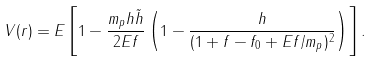Convert formula to latex. <formula><loc_0><loc_0><loc_500><loc_500>V ( r ) = E \left [ 1 - \frac { m _ { p } h \tilde { h } } { 2 E f } \left ( 1 - \frac { h } { ( 1 + f - f _ { 0 } + E f / m _ { p } ) ^ { 2 } } \right ) \right ] .</formula> 